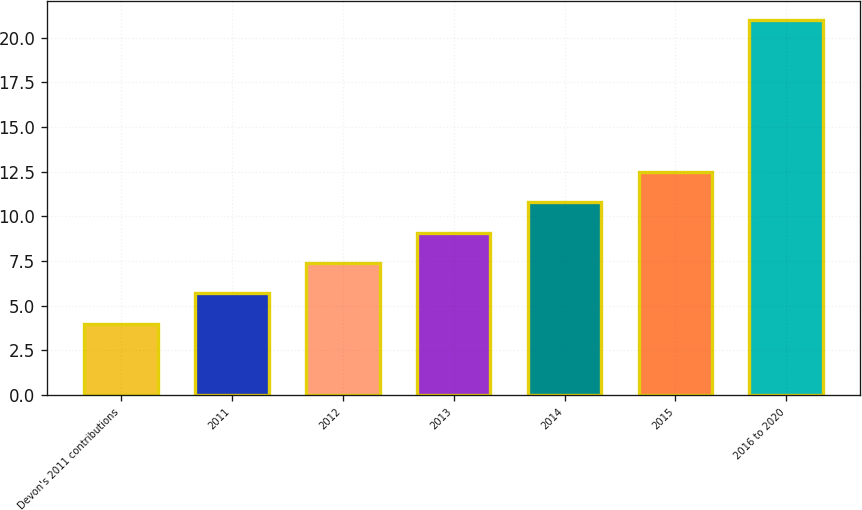Convert chart. <chart><loc_0><loc_0><loc_500><loc_500><bar_chart><fcel>Devon's 2011 contributions<fcel>2011<fcel>2012<fcel>2013<fcel>2014<fcel>2015<fcel>2016 to 2020<nl><fcel>4<fcel>5.7<fcel>7.4<fcel>9.1<fcel>10.8<fcel>12.5<fcel>21<nl></chart> 